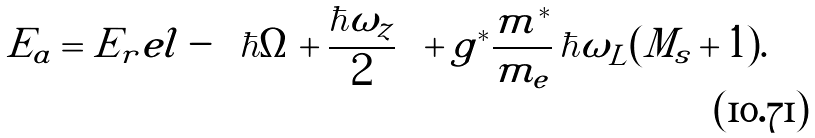<formula> <loc_0><loc_0><loc_500><loc_500>E _ { a } = E _ { r } e l - \left ( \hbar { \Omega } + \frac { \hbar { \omega } _ { z } } { 2 } \right ) + g ^ { * } \frac { m ^ { * } } { m _ { e } } \, \hbar { \omega } _ { L } ( M _ { s } + 1 ) .</formula> 